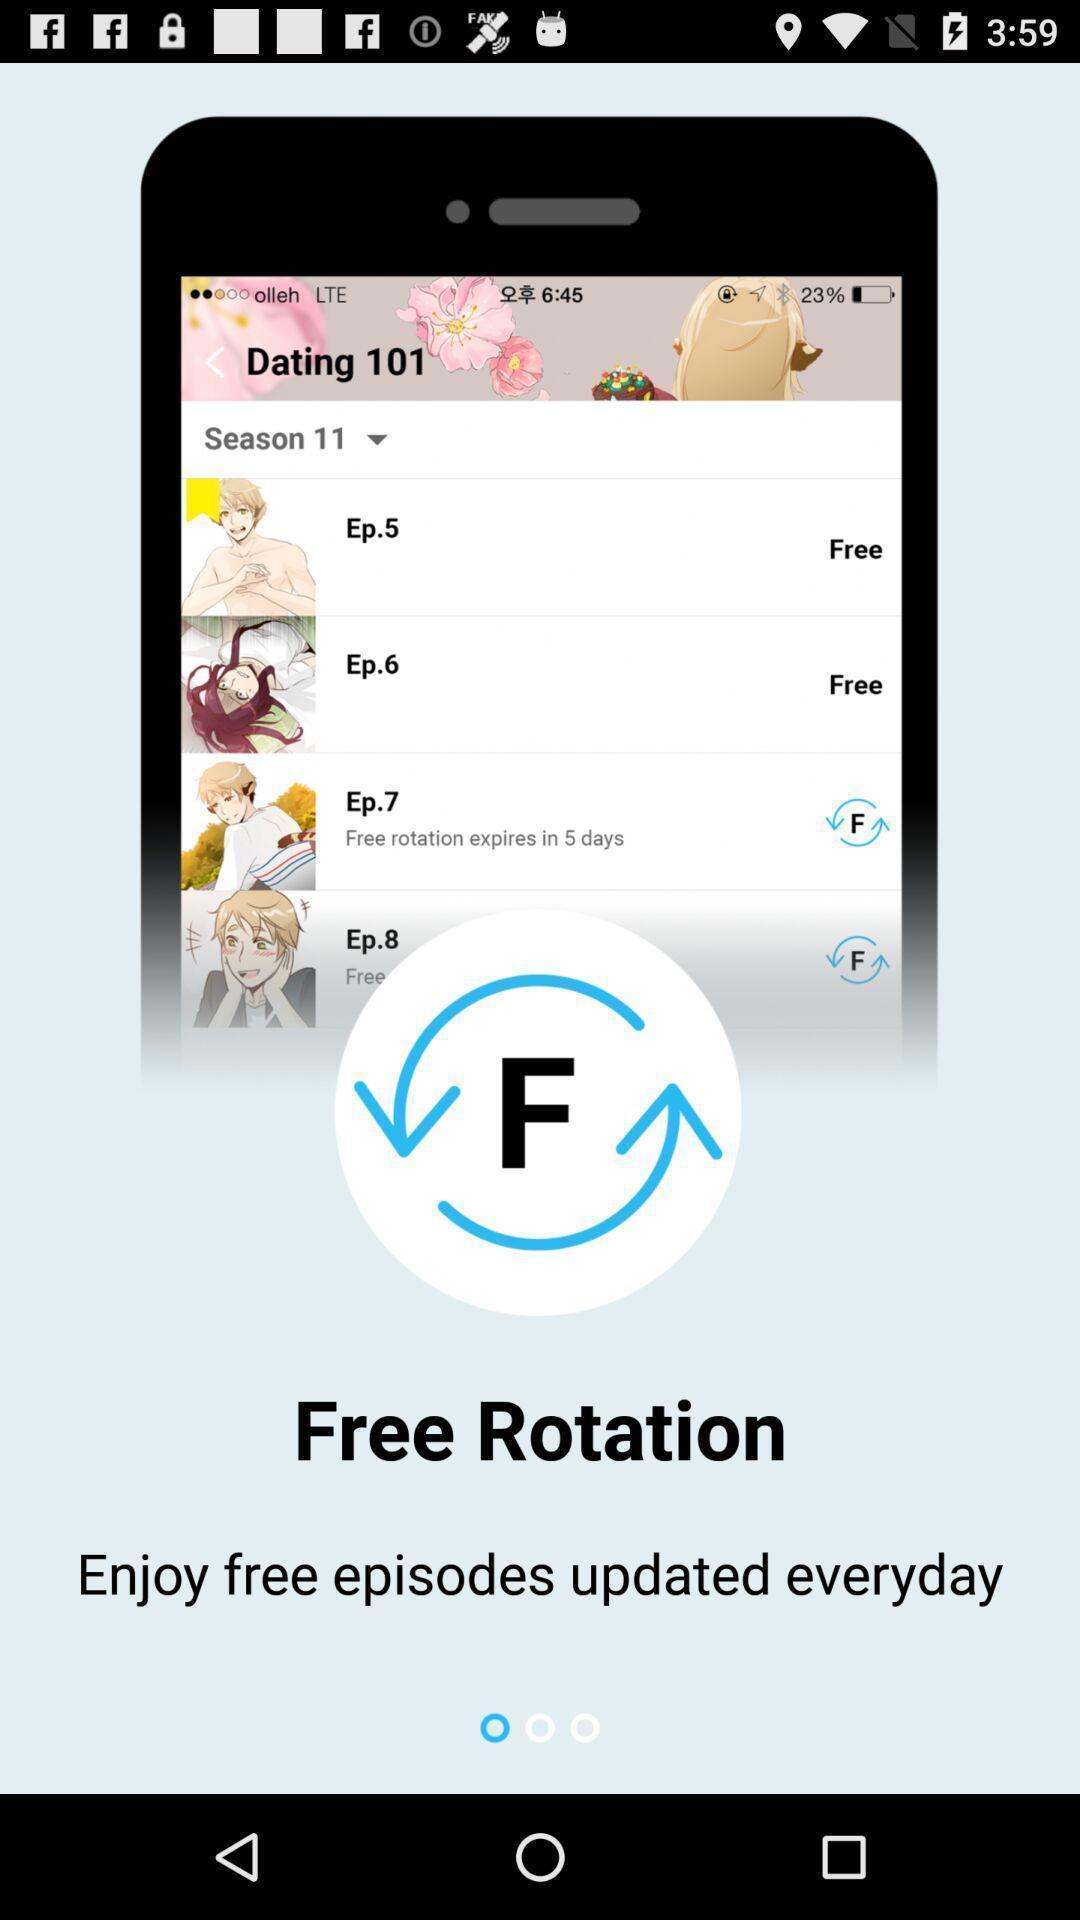What details can you identify in this image? Screen showing the welcome page of streaming app. 